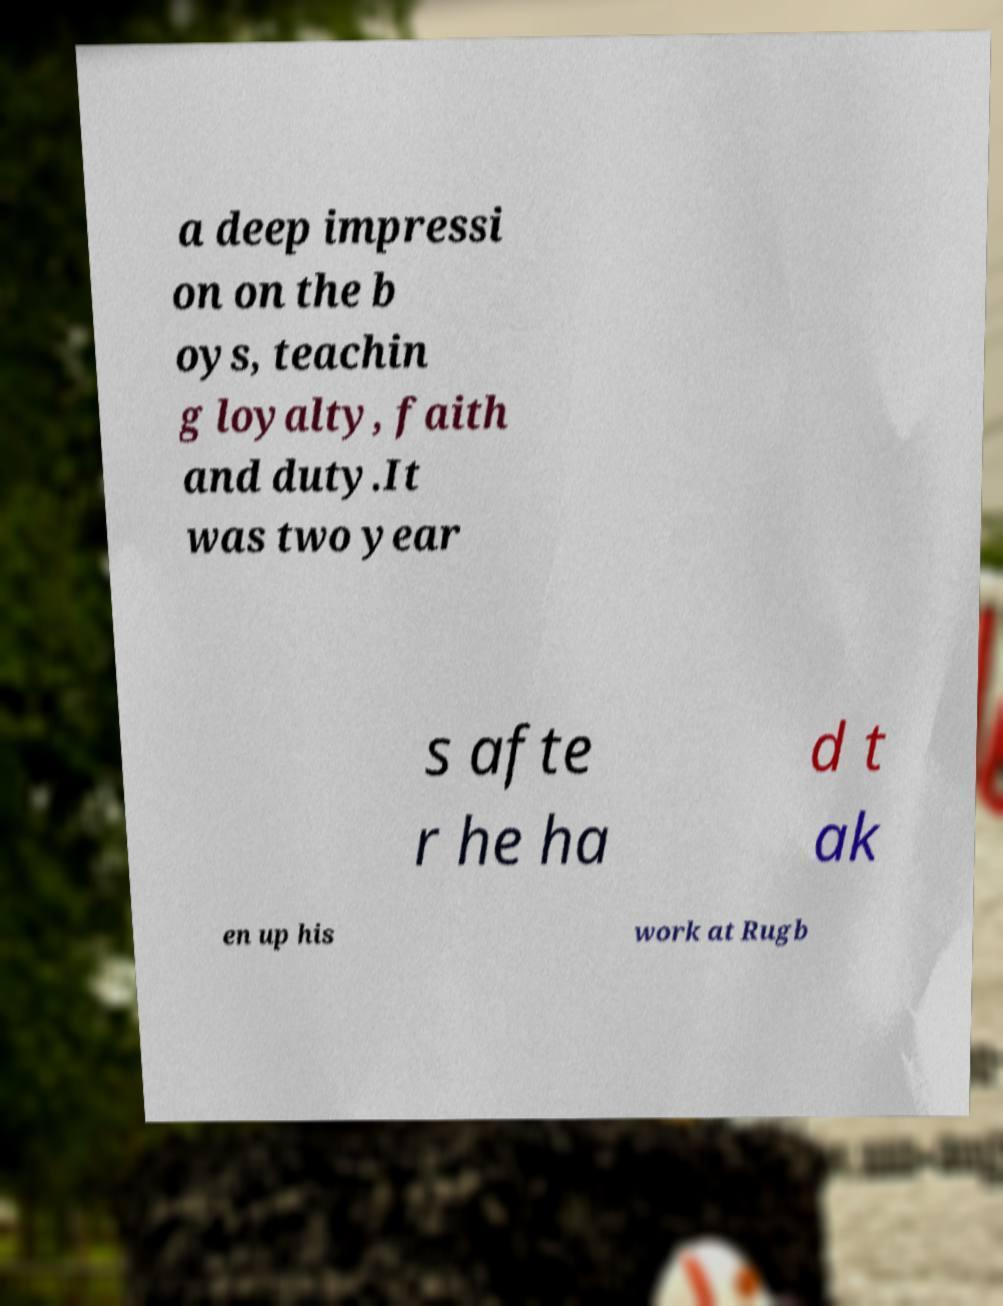Please identify and transcribe the text found in this image. a deep impressi on on the b oys, teachin g loyalty, faith and duty.It was two year s afte r he ha d t ak en up his work at Rugb 